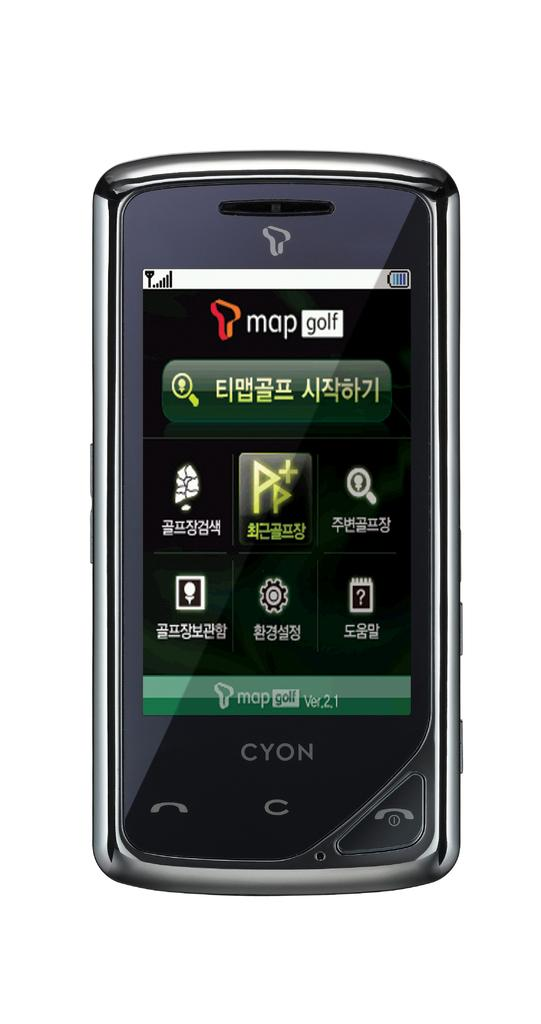<image>
Share a concise interpretation of the image provided. A Cyon phone says map golf at the top of the screen. 